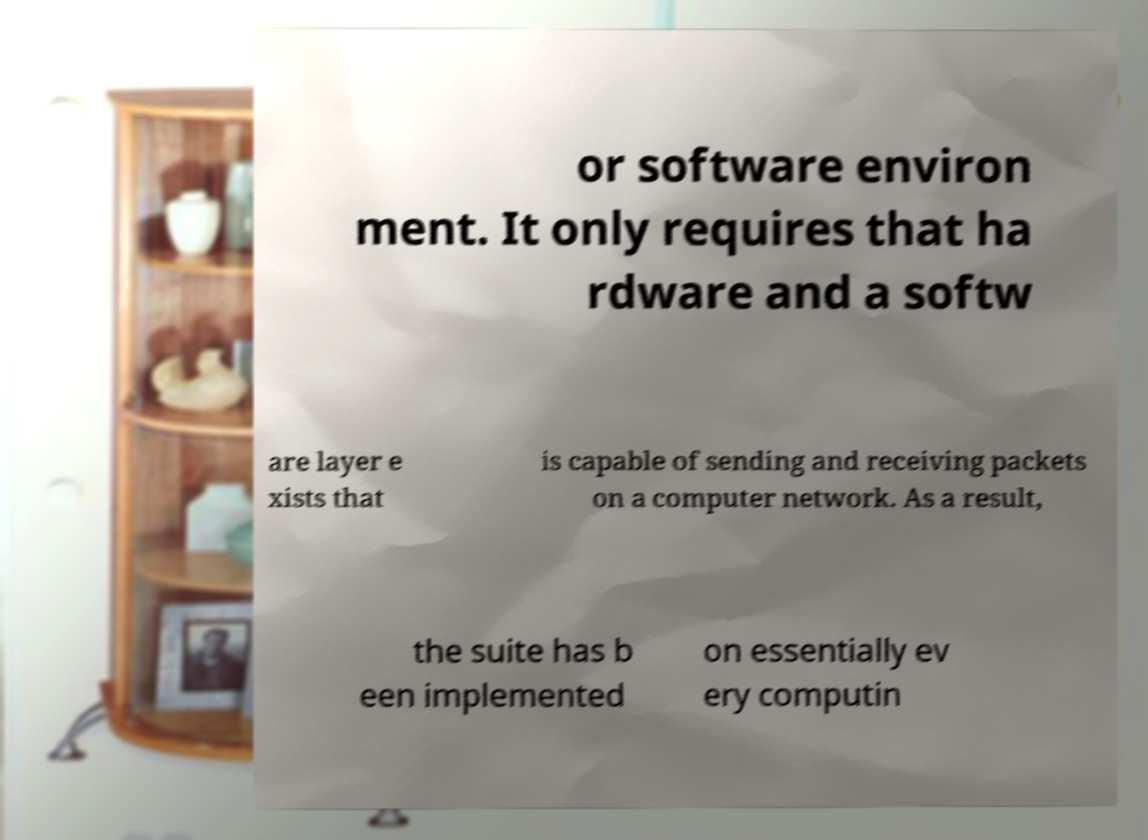Could you extract and type out the text from this image? or software environ ment. It only requires that ha rdware and a softw are layer e xists that is capable of sending and receiving packets on a computer network. As a result, the suite has b een implemented on essentially ev ery computin 